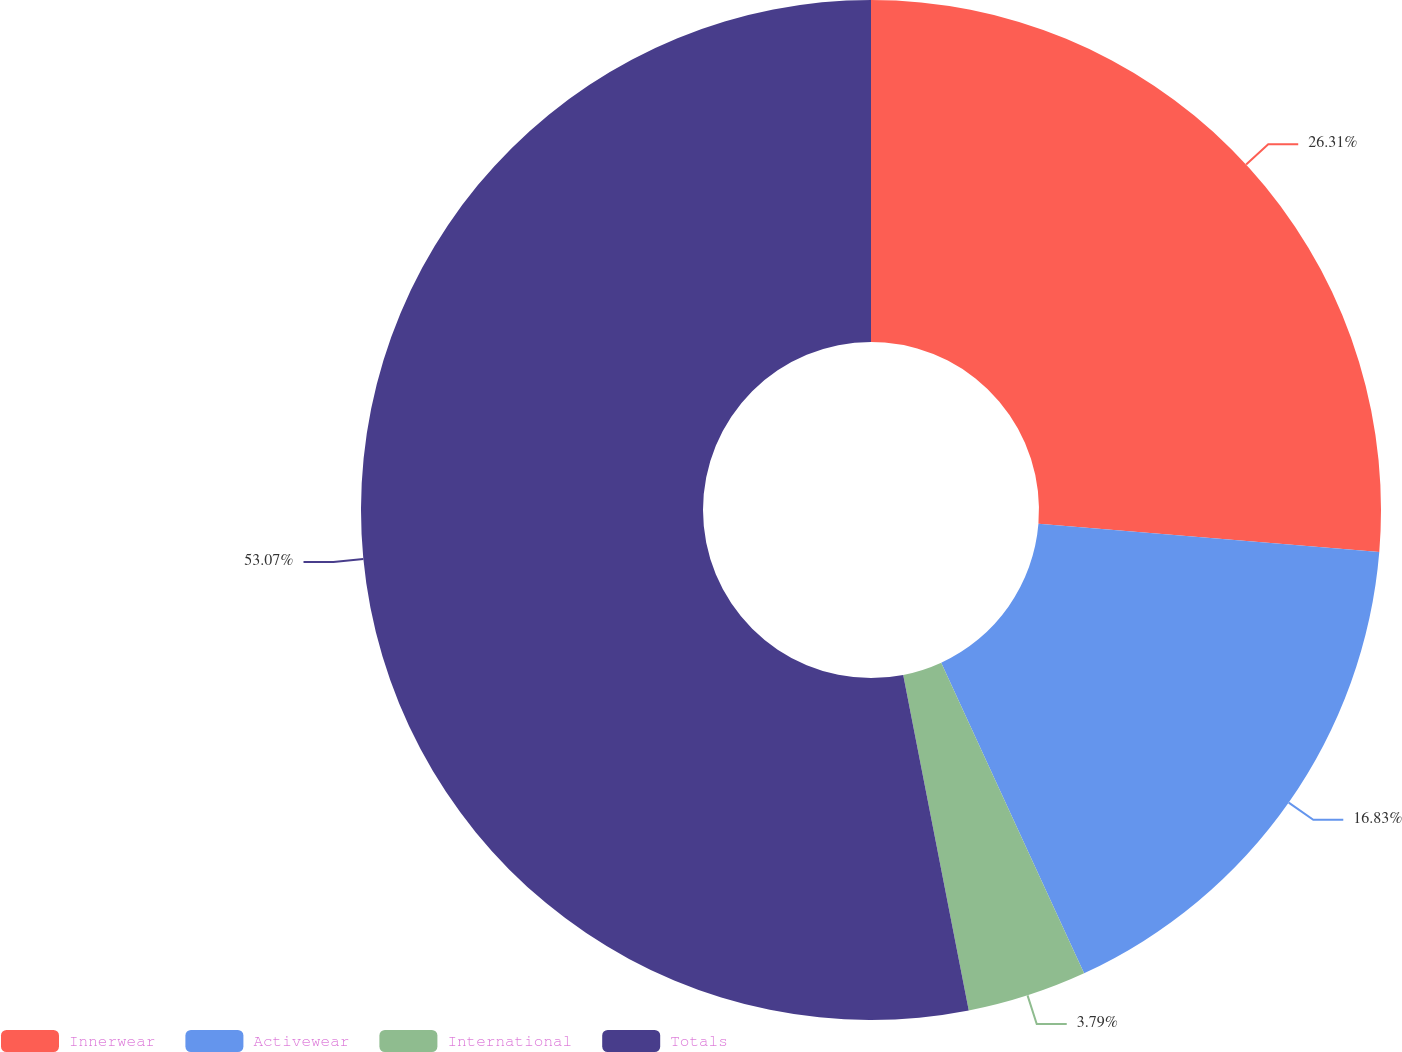<chart> <loc_0><loc_0><loc_500><loc_500><pie_chart><fcel>Innerwear<fcel>Activewear<fcel>International<fcel>Totals<nl><fcel>26.31%<fcel>16.83%<fcel>3.79%<fcel>53.07%<nl></chart> 